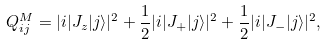Convert formula to latex. <formula><loc_0><loc_0><loc_500><loc_500>Q _ { i j } ^ { M } = | i | J _ { z } | j \rangle | ^ { 2 } + \frac { 1 } { 2 } | i | J _ { + } | j \rangle | ^ { 2 } + \frac { 1 } { 2 } | i | J _ { - } | j \rangle | ^ { 2 } ,</formula> 